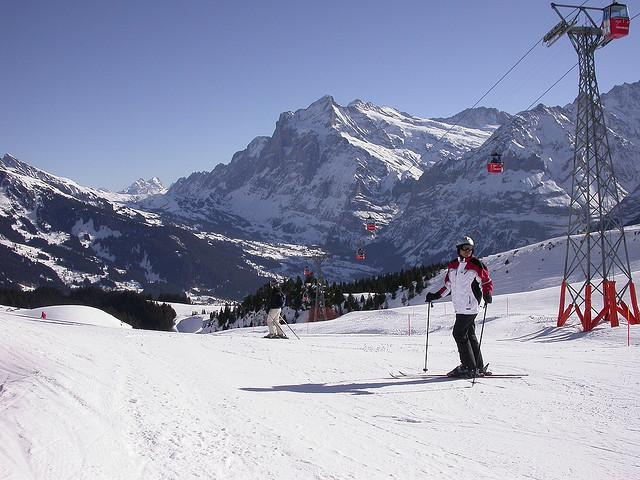Why are the bases of the towers brightly colored?

Choices:
A) sturdiness
B) sales boosting
C) safety visibility
D) marketing safety visibility 